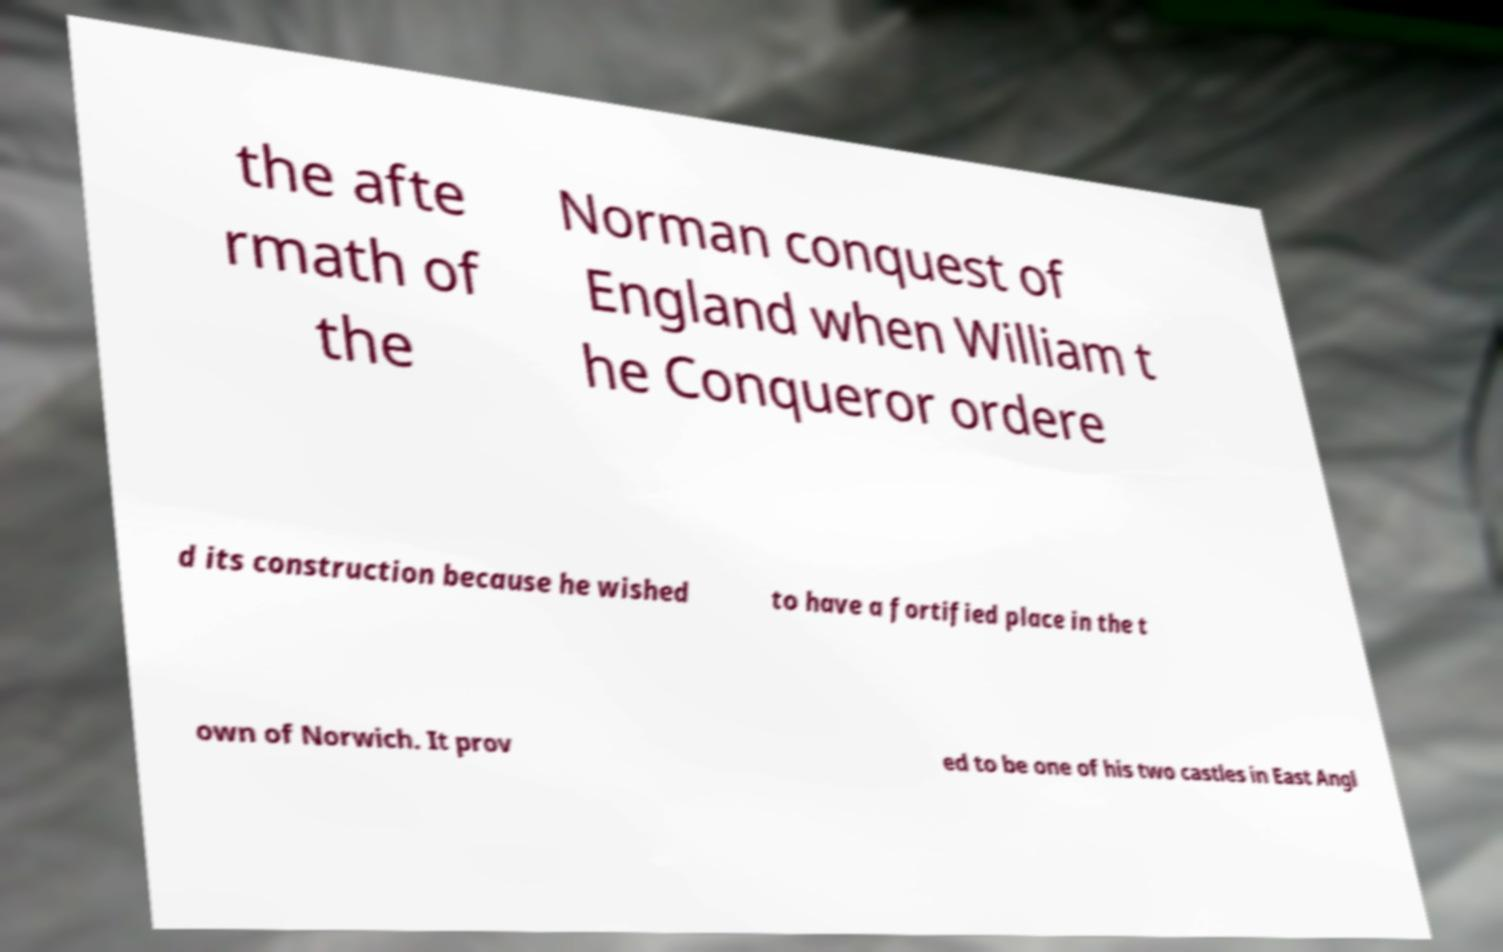Could you assist in decoding the text presented in this image and type it out clearly? the afte rmath of the Norman conquest of England when William t he Conqueror ordere d its construction because he wished to have a fortified place in the t own of Norwich. It prov ed to be one of his two castles in East Angl 